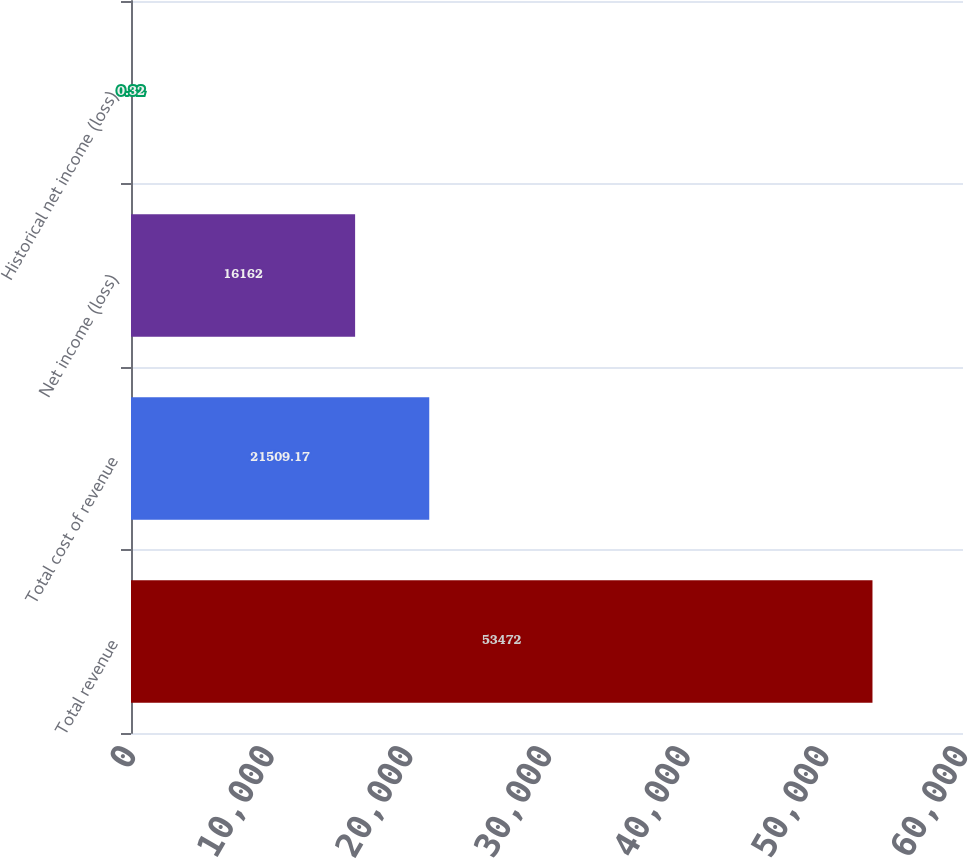Convert chart to OTSL. <chart><loc_0><loc_0><loc_500><loc_500><bar_chart><fcel>Total revenue<fcel>Total cost of revenue<fcel>Net income (loss)<fcel>Historical net income (loss)<nl><fcel>53472<fcel>21509.2<fcel>16162<fcel>0.32<nl></chart> 